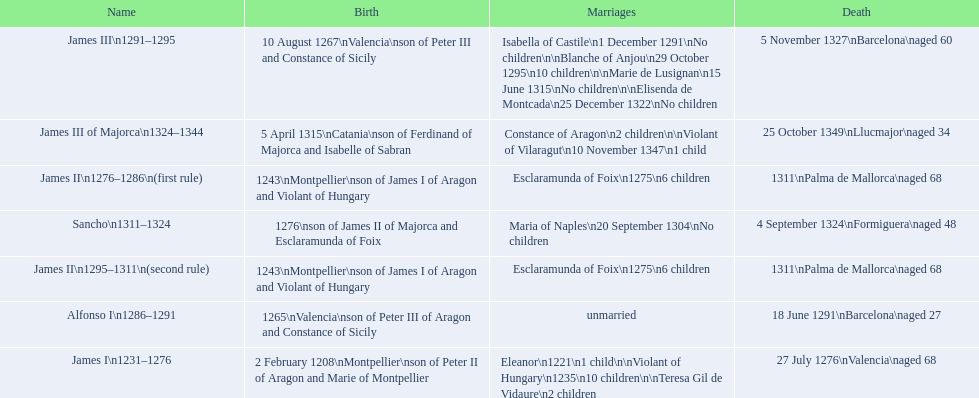James i and james ii both died at what age? 68. 